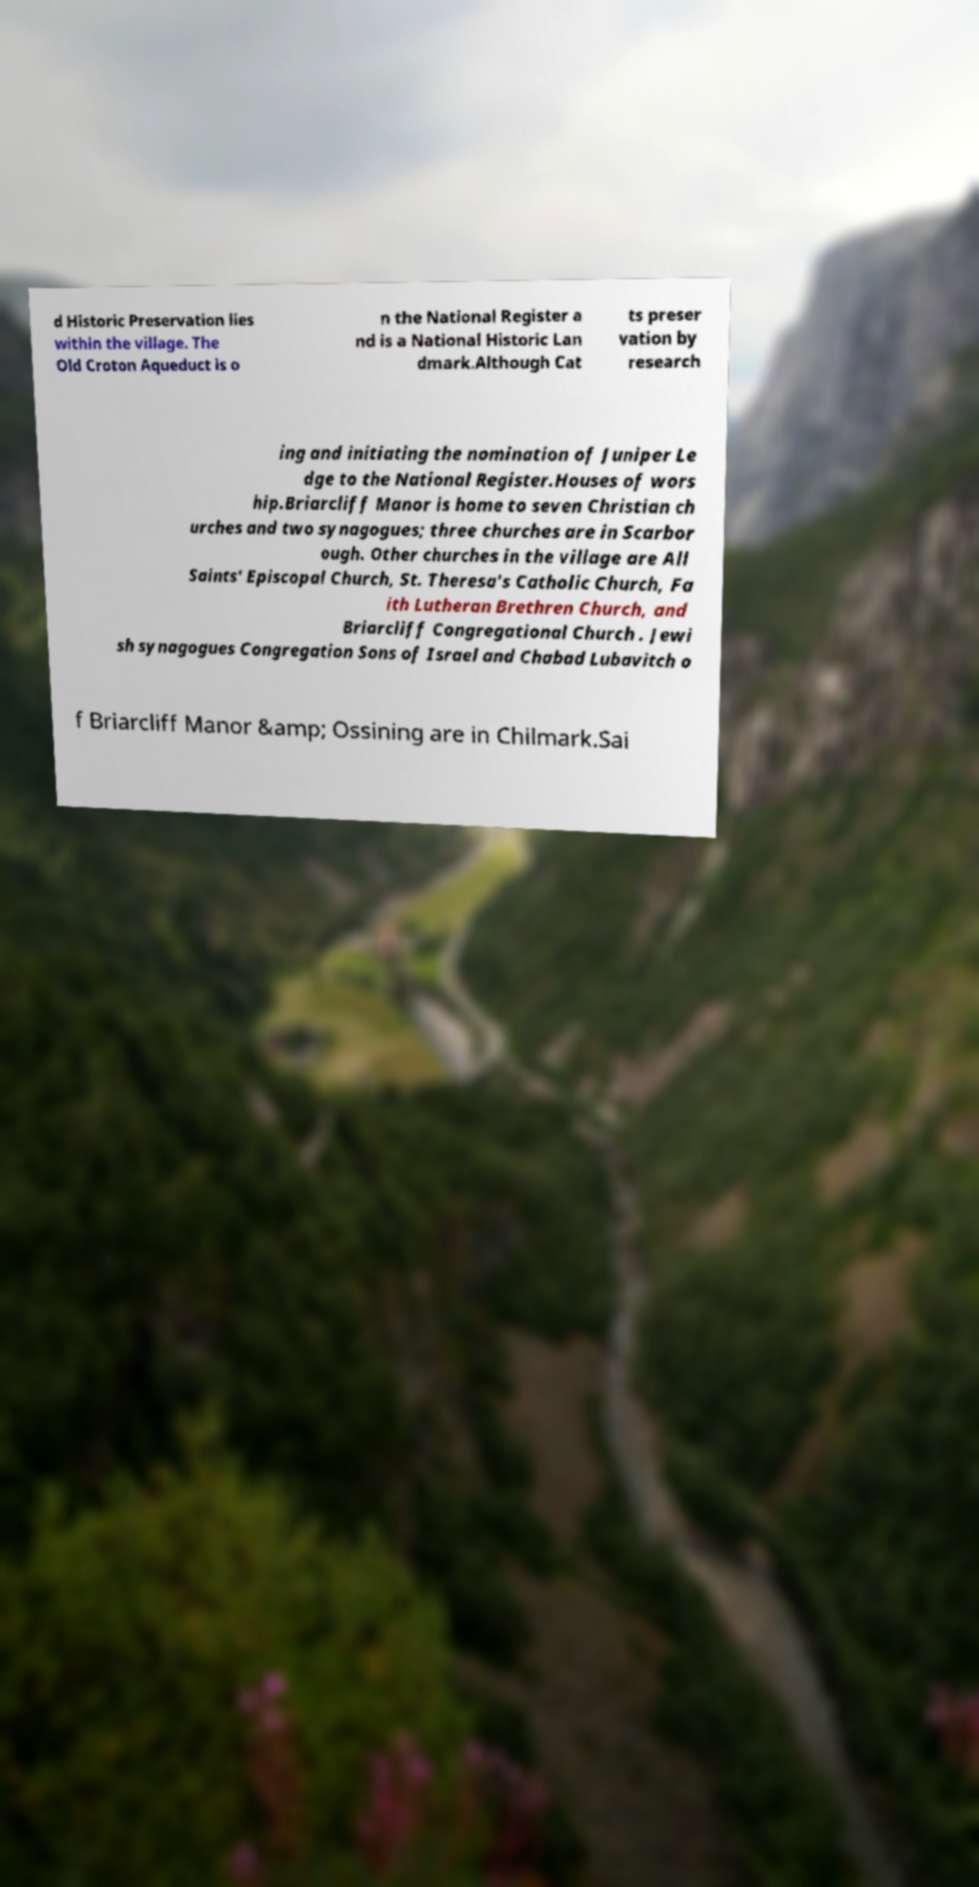Please identify and transcribe the text found in this image. d Historic Preservation lies within the village. The Old Croton Aqueduct is o n the National Register a nd is a National Historic Lan dmark.Although Cat ts preser vation by research ing and initiating the nomination of Juniper Le dge to the National Register.Houses of wors hip.Briarcliff Manor is home to seven Christian ch urches and two synagogues; three churches are in Scarbor ough. Other churches in the village are All Saints' Episcopal Church, St. Theresa's Catholic Church, Fa ith Lutheran Brethren Church, and Briarcliff Congregational Church . Jewi sh synagogues Congregation Sons of Israel and Chabad Lubavitch o f Briarcliff Manor &amp; Ossining are in Chilmark.Sai 